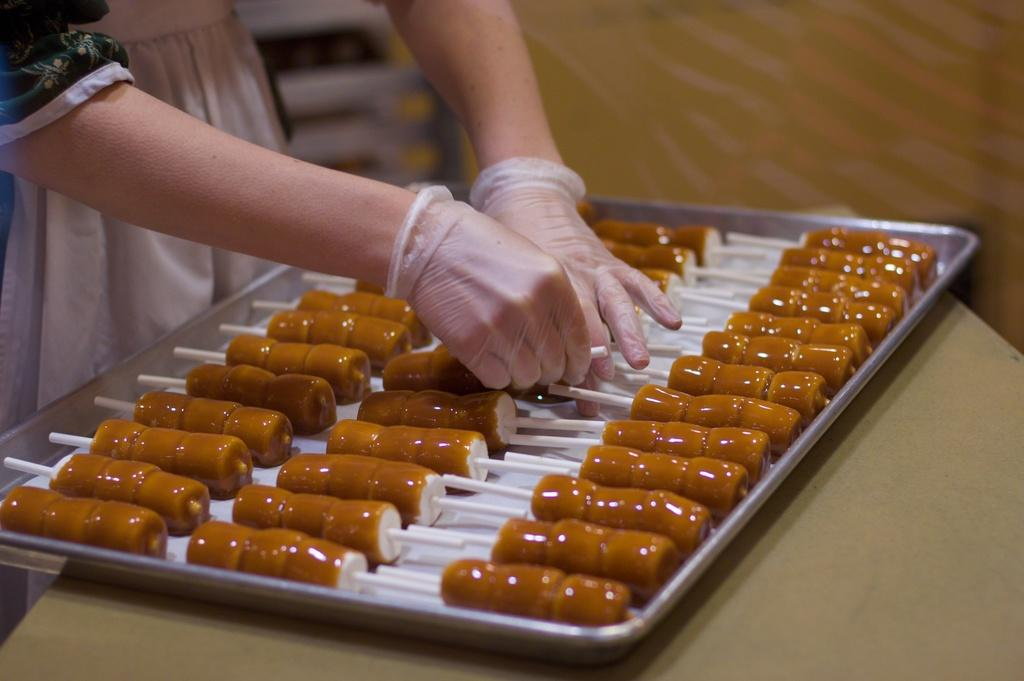What type of food is in the tray in the image? There are candies in a tray in the image. Where is the tray located? The tray is on a table. Can you describe the person on the left side of the image? There is a person wearing hand gloves on the left side of the image. What type of war is being fought on the shelf in the image? There is no shelf or war present in the image. 